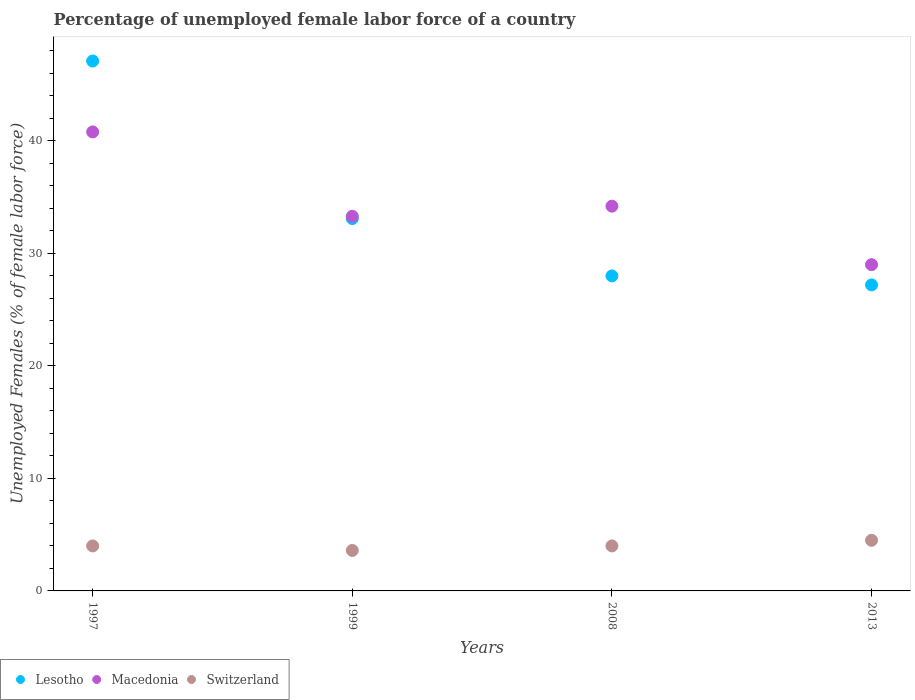Is the number of dotlines equal to the number of legend labels?
Your response must be concise. Yes. Across all years, what is the maximum percentage of unemployed female labor force in Switzerland?
Give a very brief answer. 4.5. Across all years, what is the minimum percentage of unemployed female labor force in Switzerland?
Give a very brief answer. 3.6. In which year was the percentage of unemployed female labor force in Lesotho maximum?
Ensure brevity in your answer.  1997. In which year was the percentage of unemployed female labor force in Macedonia minimum?
Your answer should be very brief. 2013. What is the total percentage of unemployed female labor force in Lesotho in the graph?
Provide a short and direct response. 135.4. What is the difference between the percentage of unemployed female labor force in Lesotho in 1997 and the percentage of unemployed female labor force in Macedonia in 2008?
Provide a short and direct response. 12.9. What is the average percentage of unemployed female labor force in Macedonia per year?
Your answer should be compact. 34.32. In the year 1999, what is the difference between the percentage of unemployed female labor force in Macedonia and percentage of unemployed female labor force in Lesotho?
Offer a terse response. 0.2. In how many years, is the percentage of unemployed female labor force in Lesotho greater than 22 %?
Your answer should be compact. 4. What is the ratio of the percentage of unemployed female labor force in Lesotho in 1997 to that in 2013?
Give a very brief answer. 1.73. Is the percentage of unemployed female labor force in Macedonia in 2008 less than that in 2013?
Your response must be concise. No. What is the difference between the highest and the lowest percentage of unemployed female labor force in Lesotho?
Your answer should be very brief. 19.9. Is it the case that in every year, the sum of the percentage of unemployed female labor force in Lesotho and percentage of unemployed female labor force in Switzerland  is greater than the percentage of unemployed female labor force in Macedonia?
Give a very brief answer. No. How many dotlines are there?
Keep it short and to the point. 3. Does the graph contain any zero values?
Keep it short and to the point. No. Where does the legend appear in the graph?
Your response must be concise. Bottom left. How many legend labels are there?
Provide a short and direct response. 3. How are the legend labels stacked?
Make the answer very short. Horizontal. What is the title of the graph?
Keep it short and to the point. Percentage of unemployed female labor force of a country. What is the label or title of the Y-axis?
Make the answer very short. Unemployed Females (% of female labor force). What is the Unemployed Females (% of female labor force) of Lesotho in 1997?
Ensure brevity in your answer.  47.1. What is the Unemployed Females (% of female labor force) of Macedonia in 1997?
Provide a short and direct response. 40.8. What is the Unemployed Females (% of female labor force) of Switzerland in 1997?
Your answer should be very brief. 4. What is the Unemployed Females (% of female labor force) in Lesotho in 1999?
Ensure brevity in your answer.  33.1. What is the Unemployed Females (% of female labor force) in Macedonia in 1999?
Offer a terse response. 33.3. What is the Unemployed Females (% of female labor force) of Switzerland in 1999?
Your answer should be compact. 3.6. What is the Unemployed Females (% of female labor force) of Lesotho in 2008?
Offer a very short reply. 28. What is the Unemployed Females (% of female labor force) of Macedonia in 2008?
Your response must be concise. 34.2. What is the Unemployed Females (% of female labor force) in Switzerland in 2008?
Make the answer very short. 4. What is the Unemployed Females (% of female labor force) in Lesotho in 2013?
Your answer should be very brief. 27.2. What is the Unemployed Females (% of female labor force) in Switzerland in 2013?
Offer a very short reply. 4.5. Across all years, what is the maximum Unemployed Females (% of female labor force) of Lesotho?
Give a very brief answer. 47.1. Across all years, what is the maximum Unemployed Females (% of female labor force) in Macedonia?
Ensure brevity in your answer.  40.8. Across all years, what is the minimum Unemployed Females (% of female labor force) of Lesotho?
Ensure brevity in your answer.  27.2. Across all years, what is the minimum Unemployed Females (% of female labor force) of Macedonia?
Give a very brief answer. 29. Across all years, what is the minimum Unemployed Females (% of female labor force) of Switzerland?
Offer a terse response. 3.6. What is the total Unemployed Females (% of female labor force) in Lesotho in the graph?
Provide a succinct answer. 135.4. What is the total Unemployed Females (% of female labor force) of Macedonia in the graph?
Provide a short and direct response. 137.3. What is the difference between the Unemployed Females (% of female labor force) in Lesotho in 1997 and that in 1999?
Give a very brief answer. 14. What is the difference between the Unemployed Females (% of female labor force) of Lesotho in 1997 and that in 2008?
Your response must be concise. 19.1. What is the difference between the Unemployed Females (% of female labor force) of Macedonia in 1997 and that in 2008?
Your response must be concise. 6.6. What is the difference between the Unemployed Females (% of female labor force) of Macedonia in 1997 and that in 2013?
Your answer should be very brief. 11.8. What is the difference between the Unemployed Females (% of female labor force) in Switzerland in 1997 and that in 2013?
Give a very brief answer. -0.5. What is the difference between the Unemployed Females (% of female labor force) in Lesotho in 1999 and that in 2008?
Your response must be concise. 5.1. What is the difference between the Unemployed Females (% of female labor force) in Switzerland in 1999 and that in 2013?
Make the answer very short. -0.9. What is the difference between the Unemployed Females (% of female labor force) of Lesotho in 2008 and that in 2013?
Offer a very short reply. 0.8. What is the difference between the Unemployed Females (% of female labor force) in Macedonia in 2008 and that in 2013?
Make the answer very short. 5.2. What is the difference between the Unemployed Females (% of female labor force) in Switzerland in 2008 and that in 2013?
Provide a succinct answer. -0.5. What is the difference between the Unemployed Females (% of female labor force) of Lesotho in 1997 and the Unemployed Females (% of female labor force) of Macedonia in 1999?
Your response must be concise. 13.8. What is the difference between the Unemployed Females (% of female labor force) of Lesotho in 1997 and the Unemployed Females (% of female labor force) of Switzerland in 1999?
Ensure brevity in your answer.  43.5. What is the difference between the Unemployed Females (% of female labor force) in Macedonia in 1997 and the Unemployed Females (% of female labor force) in Switzerland in 1999?
Provide a short and direct response. 37.2. What is the difference between the Unemployed Females (% of female labor force) of Lesotho in 1997 and the Unemployed Females (% of female labor force) of Macedonia in 2008?
Make the answer very short. 12.9. What is the difference between the Unemployed Females (% of female labor force) in Lesotho in 1997 and the Unemployed Females (% of female labor force) in Switzerland in 2008?
Provide a succinct answer. 43.1. What is the difference between the Unemployed Females (% of female labor force) in Macedonia in 1997 and the Unemployed Females (% of female labor force) in Switzerland in 2008?
Offer a terse response. 36.8. What is the difference between the Unemployed Females (% of female labor force) of Lesotho in 1997 and the Unemployed Females (% of female labor force) of Macedonia in 2013?
Offer a very short reply. 18.1. What is the difference between the Unemployed Females (% of female labor force) of Lesotho in 1997 and the Unemployed Females (% of female labor force) of Switzerland in 2013?
Keep it short and to the point. 42.6. What is the difference between the Unemployed Females (% of female labor force) in Macedonia in 1997 and the Unemployed Females (% of female labor force) in Switzerland in 2013?
Your answer should be very brief. 36.3. What is the difference between the Unemployed Females (% of female labor force) of Lesotho in 1999 and the Unemployed Females (% of female labor force) of Macedonia in 2008?
Ensure brevity in your answer.  -1.1. What is the difference between the Unemployed Females (% of female labor force) in Lesotho in 1999 and the Unemployed Females (% of female labor force) in Switzerland in 2008?
Make the answer very short. 29.1. What is the difference between the Unemployed Females (% of female labor force) of Macedonia in 1999 and the Unemployed Females (% of female labor force) of Switzerland in 2008?
Provide a short and direct response. 29.3. What is the difference between the Unemployed Females (% of female labor force) in Lesotho in 1999 and the Unemployed Females (% of female labor force) in Switzerland in 2013?
Make the answer very short. 28.6. What is the difference between the Unemployed Females (% of female labor force) of Macedonia in 1999 and the Unemployed Females (% of female labor force) of Switzerland in 2013?
Your response must be concise. 28.8. What is the difference between the Unemployed Females (% of female labor force) in Lesotho in 2008 and the Unemployed Females (% of female labor force) in Macedonia in 2013?
Your answer should be very brief. -1. What is the difference between the Unemployed Females (% of female labor force) in Macedonia in 2008 and the Unemployed Females (% of female labor force) in Switzerland in 2013?
Your answer should be very brief. 29.7. What is the average Unemployed Females (% of female labor force) in Lesotho per year?
Your answer should be very brief. 33.85. What is the average Unemployed Females (% of female labor force) of Macedonia per year?
Offer a terse response. 34.33. What is the average Unemployed Females (% of female labor force) of Switzerland per year?
Your answer should be compact. 4.03. In the year 1997, what is the difference between the Unemployed Females (% of female labor force) in Lesotho and Unemployed Females (% of female labor force) in Switzerland?
Keep it short and to the point. 43.1. In the year 1997, what is the difference between the Unemployed Females (% of female labor force) of Macedonia and Unemployed Females (% of female labor force) of Switzerland?
Give a very brief answer. 36.8. In the year 1999, what is the difference between the Unemployed Females (% of female labor force) of Lesotho and Unemployed Females (% of female labor force) of Switzerland?
Provide a succinct answer. 29.5. In the year 1999, what is the difference between the Unemployed Females (% of female labor force) of Macedonia and Unemployed Females (% of female labor force) of Switzerland?
Provide a short and direct response. 29.7. In the year 2008, what is the difference between the Unemployed Females (% of female labor force) of Lesotho and Unemployed Females (% of female labor force) of Macedonia?
Ensure brevity in your answer.  -6.2. In the year 2008, what is the difference between the Unemployed Females (% of female labor force) of Lesotho and Unemployed Females (% of female labor force) of Switzerland?
Offer a very short reply. 24. In the year 2008, what is the difference between the Unemployed Females (% of female labor force) in Macedonia and Unemployed Females (% of female labor force) in Switzerland?
Provide a succinct answer. 30.2. In the year 2013, what is the difference between the Unemployed Females (% of female labor force) in Lesotho and Unemployed Females (% of female labor force) in Switzerland?
Ensure brevity in your answer.  22.7. What is the ratio of the Unemployed Females (% of female labor force) in Lesotho in 1997 to that in 1999?
Your answer should be compact. 1.42. What is the ratio of the Unemployed Females (% of female labor force) in Macedonia in 1997 to that in 1999?
Your response must be concise. 1.23. What is the ratio of the Unemployed Females (% of female labor force) in Lesotho in 1997 to that in 2008?
Your response must be concise. 1.68. What is the ratio of the Unemployed Females (% of female labor force) of Macedonia in 1997 to that in 2008?
Your response must be concise. 1.19. What is the ratio of the Unemployed Females (% of female labor force) of Switzerland in 1997 to that in 2008?
Offer a terse response. 1. What is the ratio of the Unemployed Females (% of female labor force) of Lesotho in 1997 to that in 2013?
Provide a short and direct response. 1.73. What is the ratio of the Unemployed Females (% of female labor force) of Macedonia in 1997 to that in 2013?
Give a very brief answer. 1.41. What is the ratio of the Unemployed Females (% of female labor force) of Switzerland in 1997 to that in 2013?
Give a very brief answer. 0.89. What is the ratio of the Unemployed Females (% of female labor force) of Lesotho in 1999 to that in 2008?
Provide a short and direct response. 1.18. What is the ratio of the Unemployed Females (% of female labor force) in Macedonia in 1999 to that in 2008?
Make the answer very short. 0.97. What is the ratio of the Unemployed Females (% of female labor force) in Switzerland in 1999 to that in 2008?
Keep it short and to the point. 0.9. What is the ratio of the Unemployed Females (% of female labor force) of Lesotho in 1999 to that in 2013?
Ensure brevity in your answer.  1.22. What is the ratio of the Unemployed Females (% of female labor force) of Macedonia in 1999 to that in 2013?
Ensure brevity in your answer.  1.15. What is the ratio of the Unemployed Females (% of female labor force) in Lesotho in 2008 to that in 2013?
Give a very brief answer. 1.03. What is the ratio of the Unemployed Females (% of female labor force) in Macedonia in 2008 to that in 2013?
Ensure brevity in your answer.  1.18. What is the ratio of the Unemployed Females (% of female labor force) of Switzerland in 2008 to that in 2013?
Ensure brevity in your answer.  0.89. What is the difference between the highest and the second highest Unemployed Females (% of female labor force) of Lesotho?
Provide a succinct answer. 14. What is the difference between the highest and the second highest Unemployed Females (% of female labor force) of Macedonia?
Your response must be concise. 6.6. What is the difference between the highest and the second highest Unemployed Females (% of female labor force) in Switzerland?
Provide a succinct answer. 0.5. What is the difference between the highest and the lowest Unemployed Females (% of female labor force) in Lesotho?
Provide a short and direct response. 19.9. 